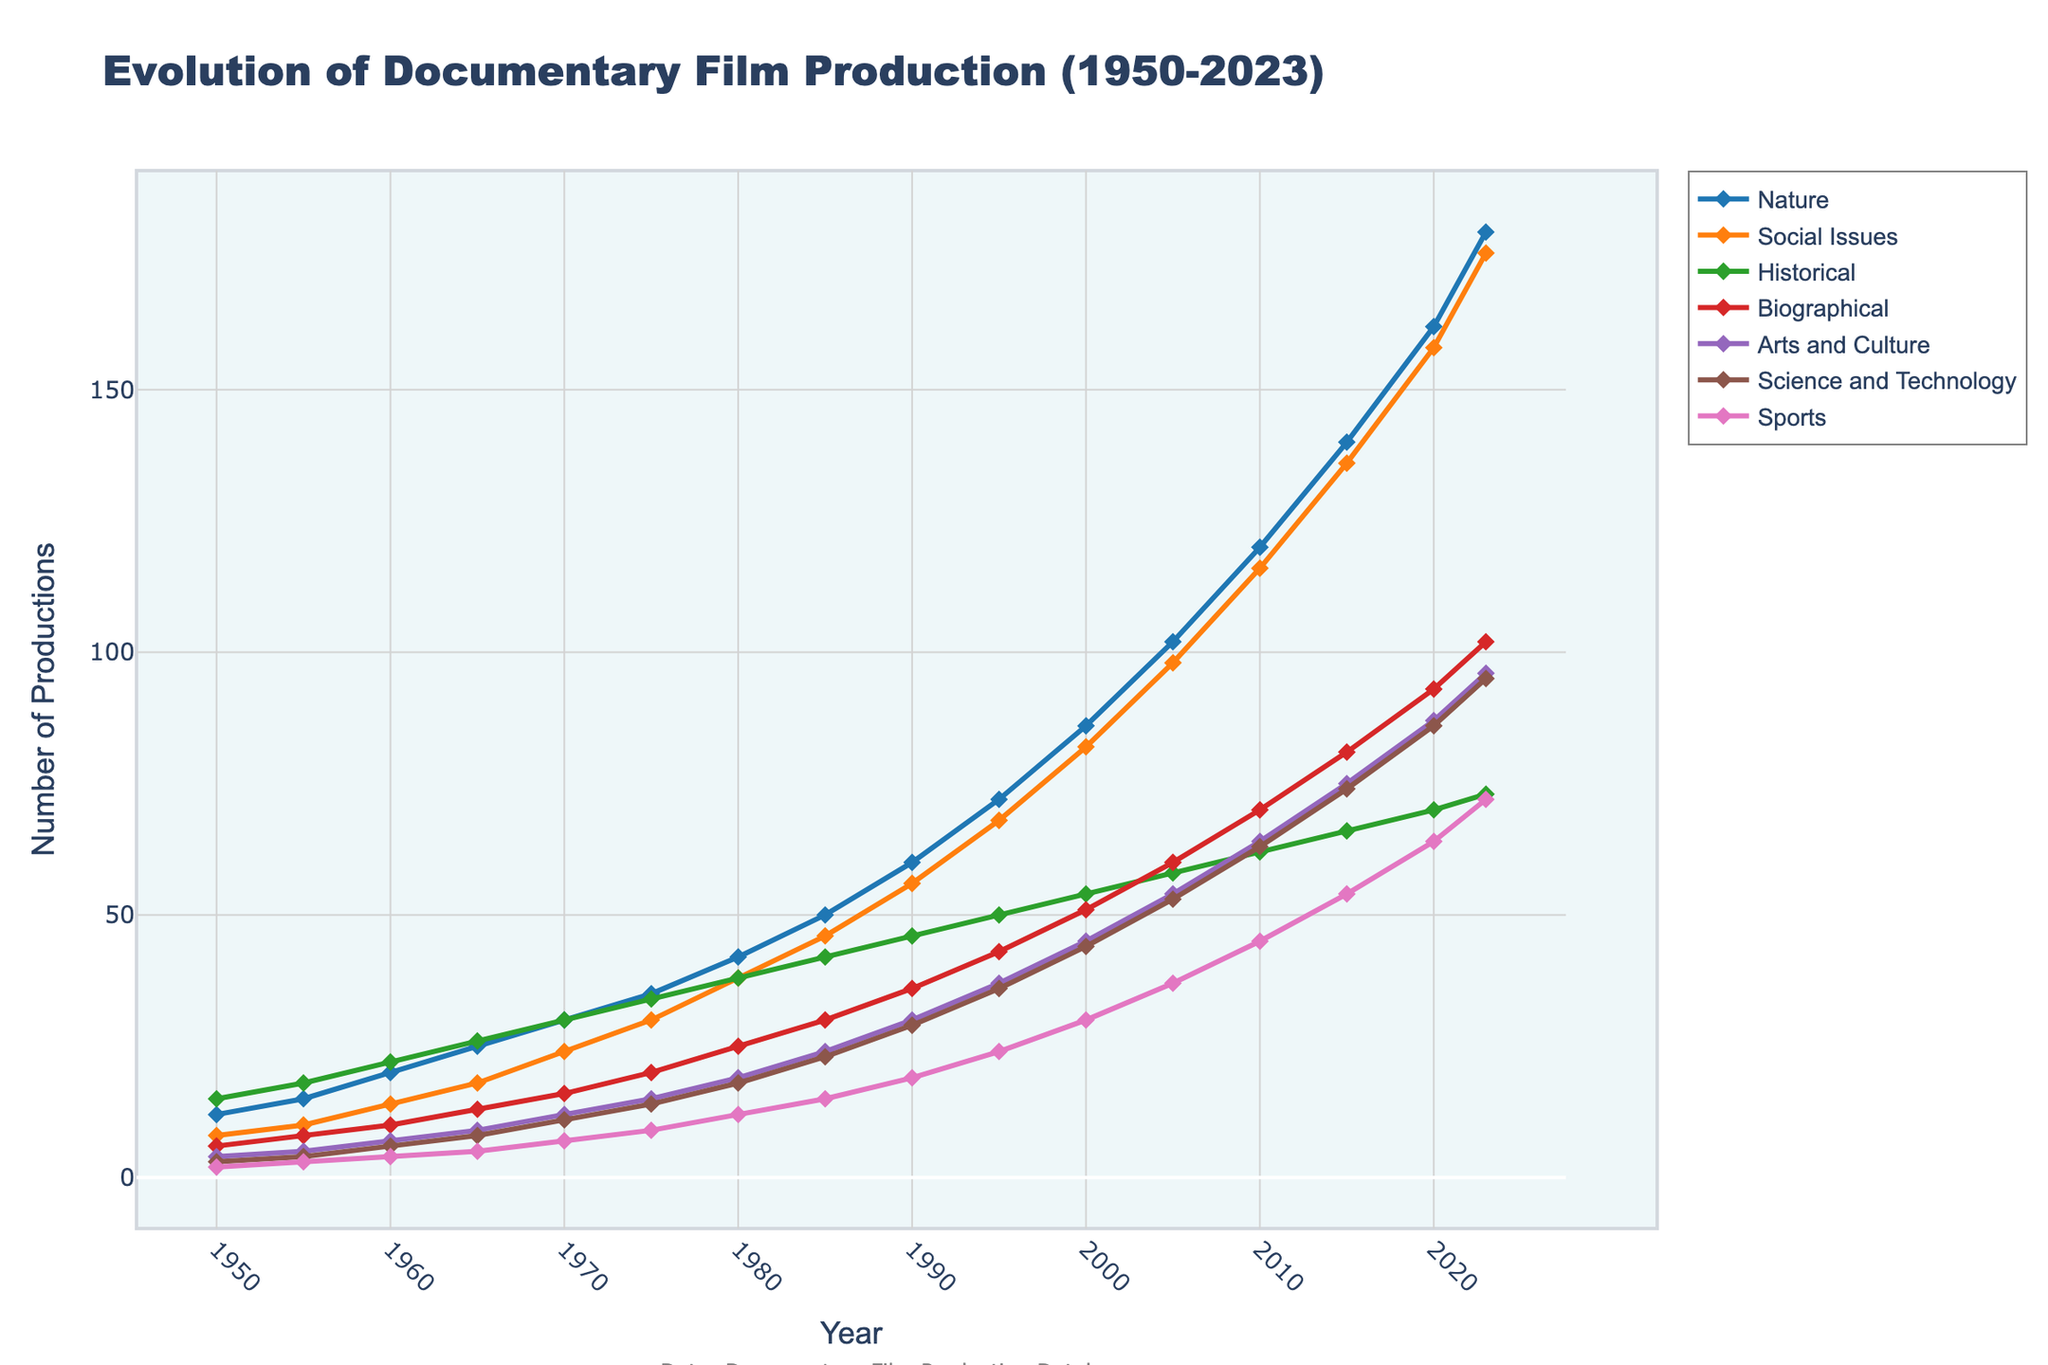what genre had the highest production in 1990? Look at the year 1990 and compare the values for each genre. Nature has 60, which is the highest among the genres.
Answer: Nature Between which years did the number of Sports documentaries increase the most? Calculate the difference in the number of Sports documentaries produced between consecutive years and identify the largest increase. From 2010 to 2015, the numbers go from 45 to 54, an increase of 9, which is the most significant.
Answer: 2010 to 2015 How much did the production of Biographical documentaries grow from 1970 to 2023? Subtract the number of Biographical documentaries in 1970 from the number in 2023. The values are 16 and 102, respectively. 102 - 16 = 86.
Answer: 86 Which genre had the smallest increase in production from 1980 to 2023? Calculate the increase for each genre from 1980 to 2023 and identify the smallest one. Science and Technology increased from 18 to 95, an increase of 77, which is the smallest increase among the genres.
Answer: Science and Technology In what year did Biographical documentaries surpass 80 productions? Look for the first year where the Biographical genre has more than 80 productions. In 2015, Biographical documentaries had 81 productions.
Answer: 2015 What is the average number of Historical documentaries produced in the 2000s (2000-2009 inclusive)? Compute the average by summing the number of Historical documentaries from 2000, 2005, and dividing by 2 (since we are dealing with two data points). (54 + 58) = 112 / 2 = 56.
Answer: 56 How did the production of Science and Technology documentaries change from 1960 to 2000? Find the difference between the number of Science and Technology documentaries in 2000 and 1960. In 2000, it was 44, and in 1960, it was 6. 44 - 6 = 38.
Answer: Increased by 38 Which two genres had the closest number of productions in 1985? Compare the numbers for all genres in 1985 and find the smallest difference. Biographical (30) and Arts and Culture (24) have the closest numbers with a difference of 6.
Answer: Biographical and Arts and Culture 